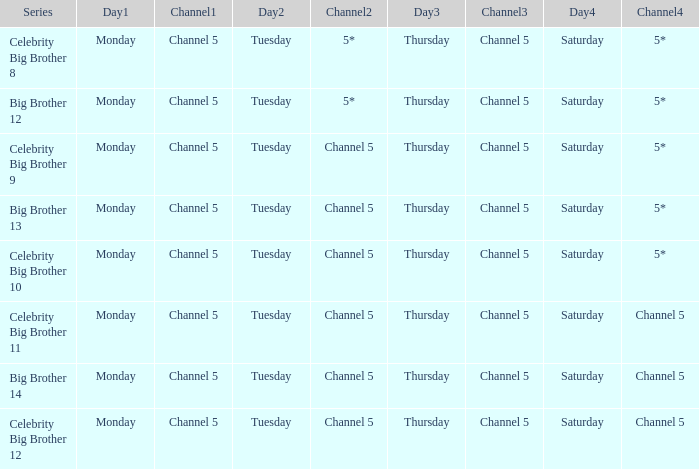Which Tuesday does big brother 12 air? 5*. 